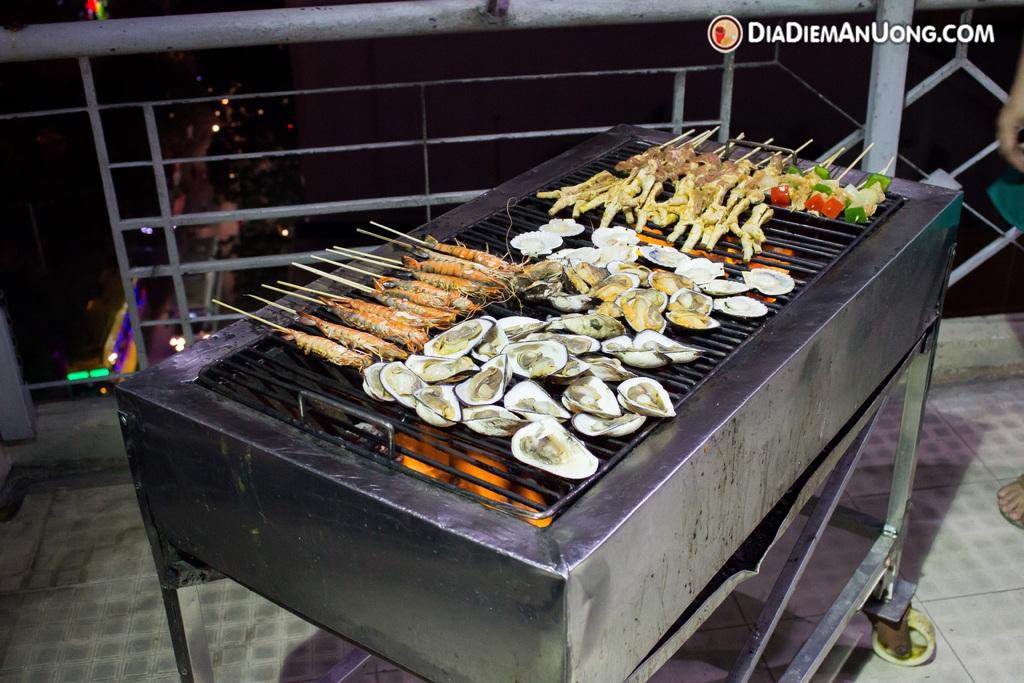What's the website in the upper right?
Offer a terse response. Diadiemanuong.com. 